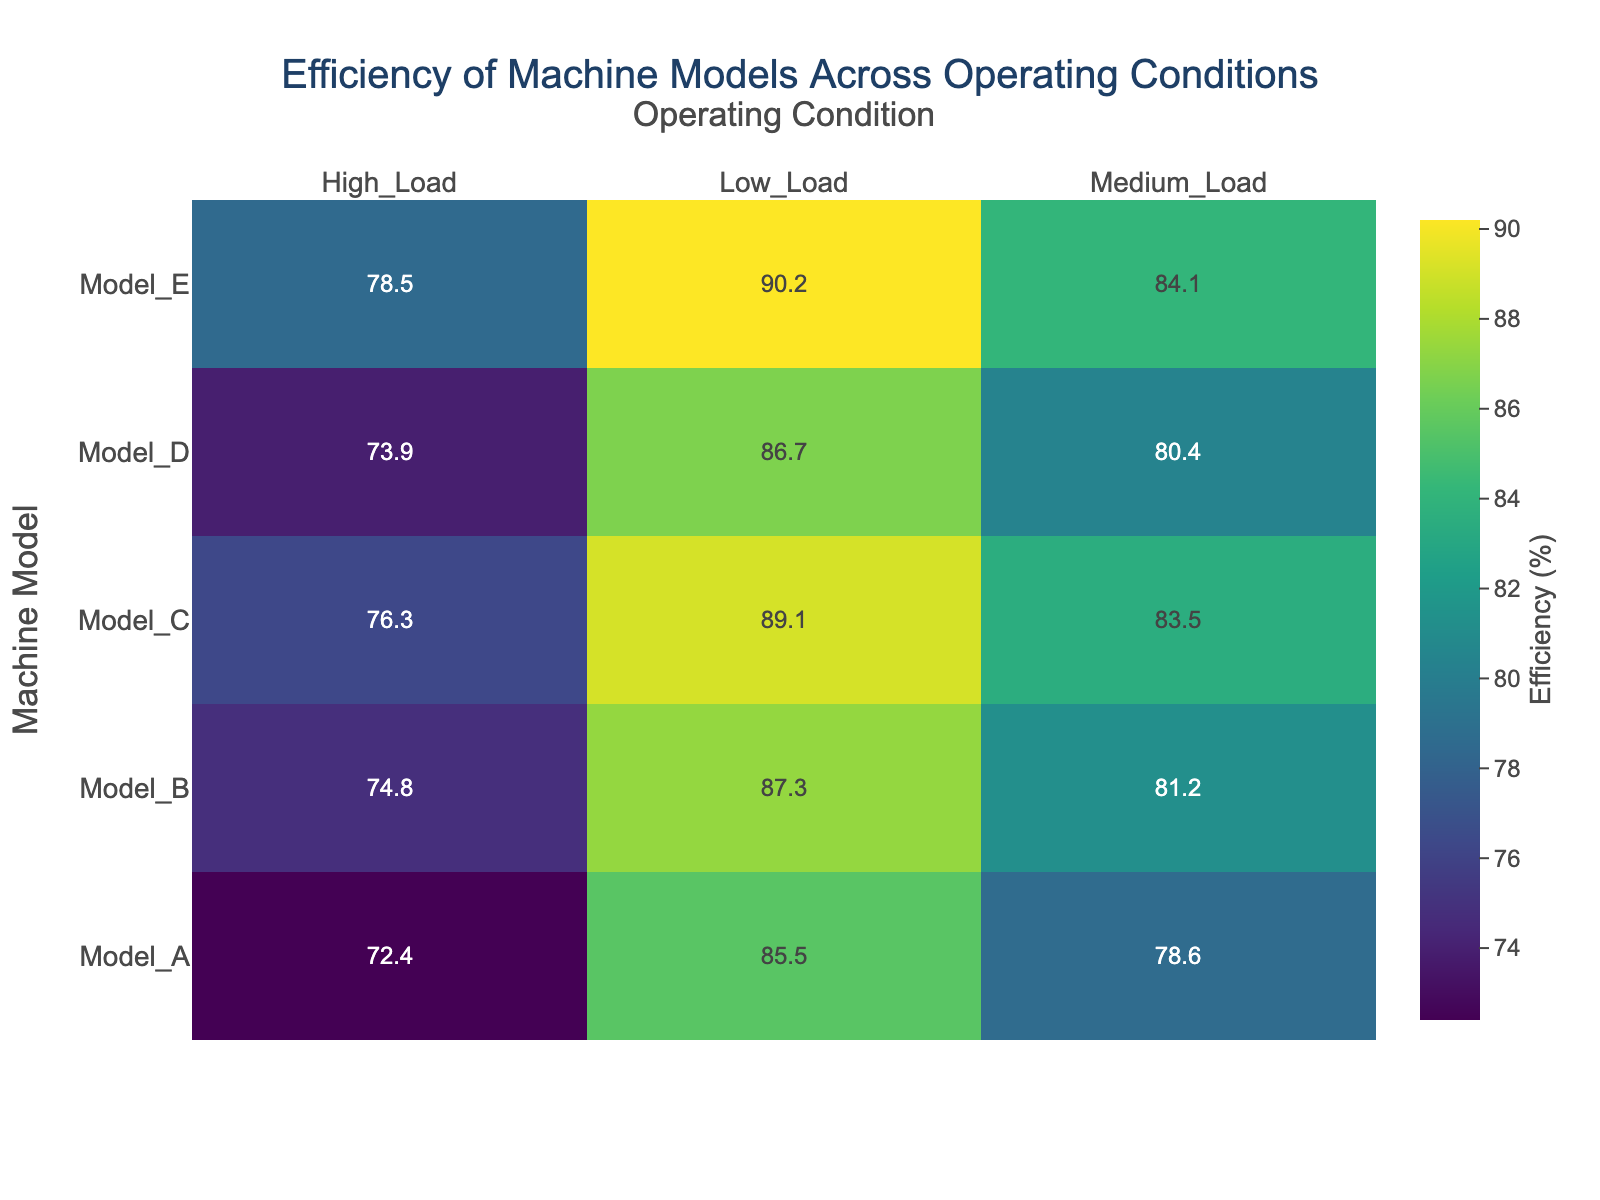What is the title of the heatmap? The title of the heatmap is displayed at the center top of the figure.
Answer: Efficiency of Machine Models Across Operating Conditions What are the operating conditions listed in the heatmap? The operating conditions are displayed along the top x-axis of the heatmap.
Answer: Low_Load, Medium_Load, High_Load Which machine model shows the highest efficiency under High_Load conditions? Locate the High_Load column and find the highest value in that column.
Answer: Model_E What is the range of efficiencies displayed in the heatmap? The range is determined by the minimum and maximum values in the heatmap.
Answer: 72.4 to 90.2 How does the efficiency of Model_A under Low_Load conditions compare to Model_B under the same conditions? Compare the efficiency values in the Low_Load row for both Model_A and Model_B.
Answer: Model_B is more efficient Which machine model has the most consistent efficiency across all conditions? Find the model with the smallest variation in efficiency values across all operating conditions.
Answer: Model_E What is the difference in efficiency between Model_E and Model_D under Medium_Load conditions? Subtract the efficiency of Model_D from Model_E under Medium_Load.
Answer: 84.1 - 80.4 = 3.7 Among the models shown, which model under Medium_Load conditions has the lowest efficiency? Locate the Medium_Load column and find the smallest value in that column.
Answer: Model_A What is the average efficiency of Model_C across all operating conditions? Add the efficiencies of Model_C and divide by the number of conditions.
Answer: (89.1 + 83.5 + 76.3) / 3 = 83.0 How does the efficiency trend of all models change as the load increases from Low to High? Observe how the efficiency values of all models change from Low_Load to Medium_Load to High_Load.
Answer: Decreases 